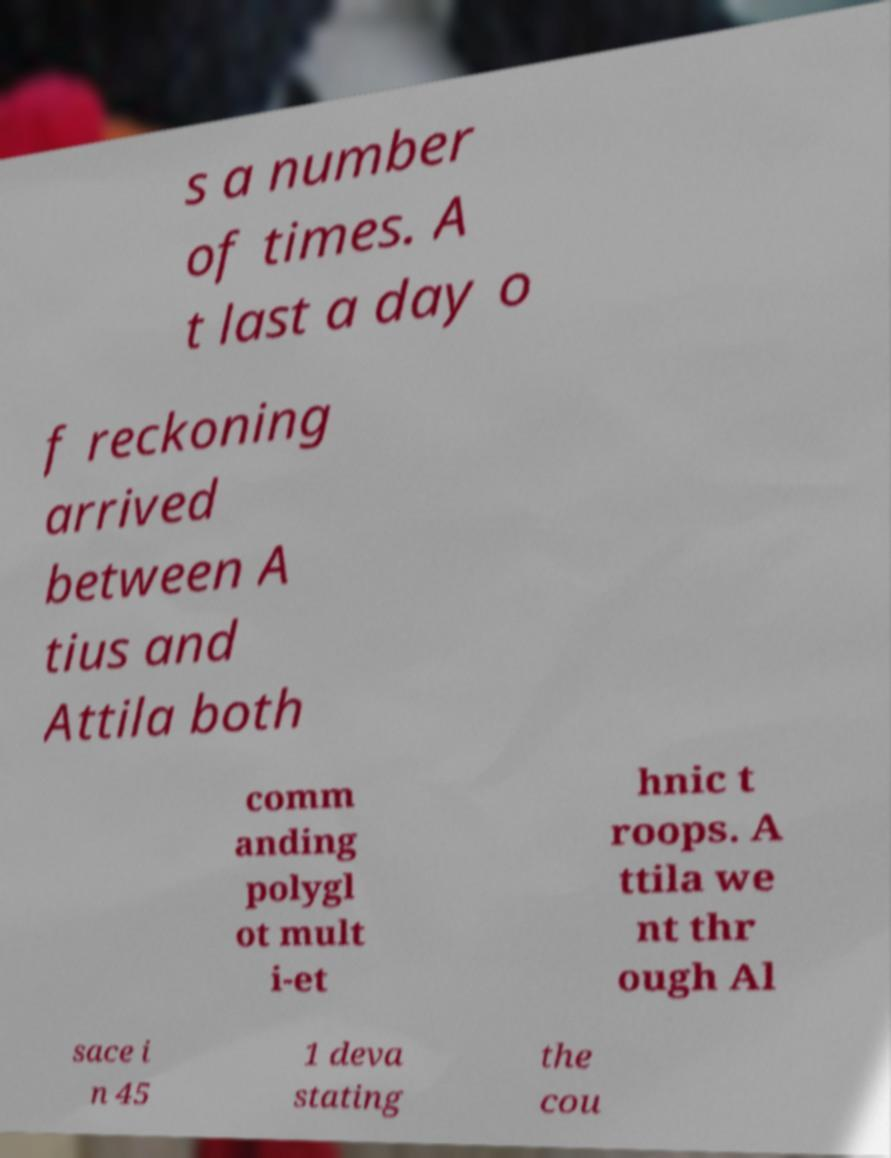There's text embedded in this image that I need extracted. Can you transcribe it verbatim? s a number of times. A t last a day o f reckoning arrived between A tius and Attila both comm anding polygl ot mult i-et hnic t roops. A ttila we nt thr ough Al sace i n 45 1 deva stating the cou 